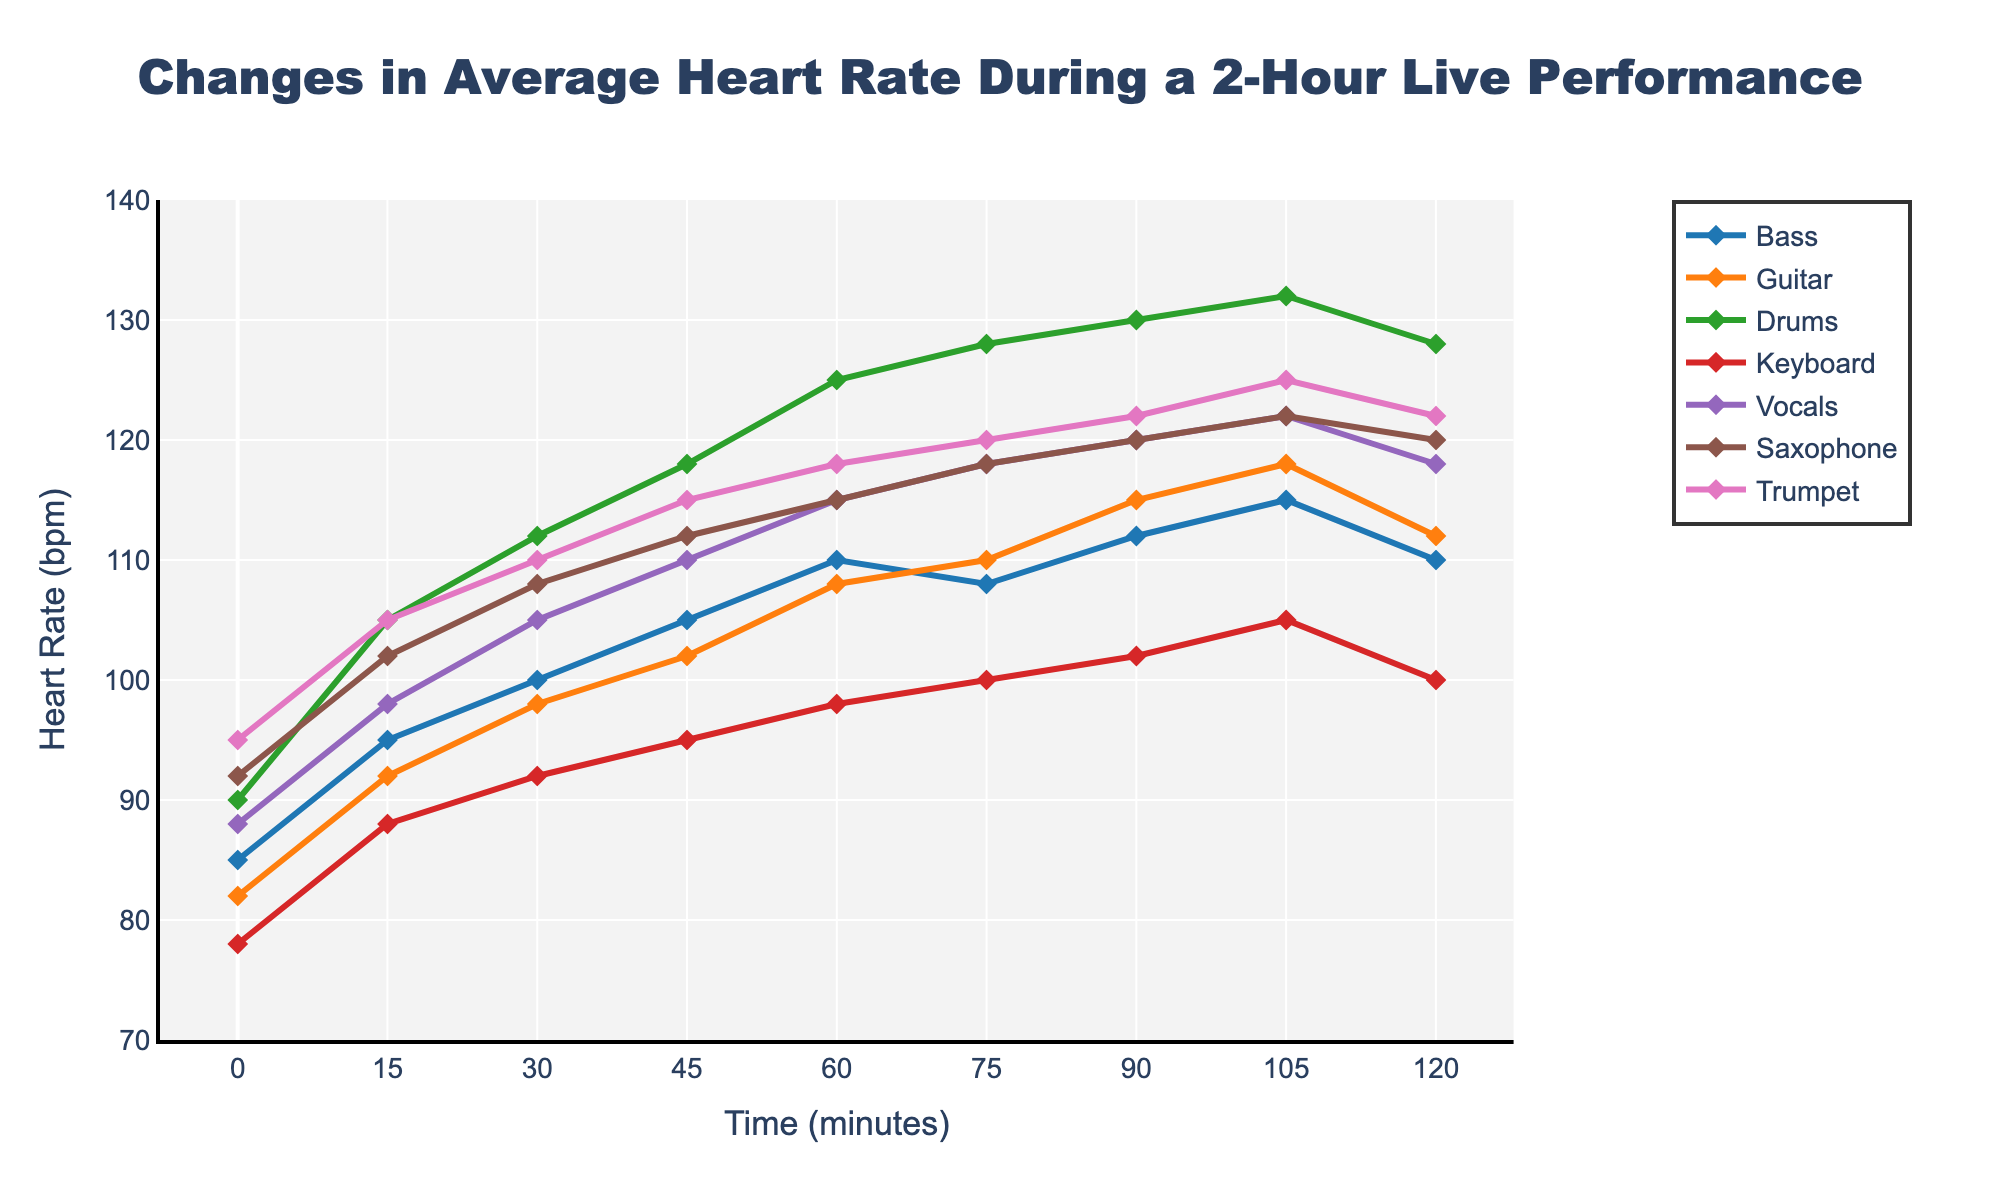Which instrument shows the highest heart rate at the 120-minute mark? Look at the values for each instrument at the 120-minute mark to identify the highest number. Drums have a heart rate of 128 bpm, which is the highest among all instruments.
Answer: Drums Which instrument shows the lowest initial heart rate at the 0-minute mark? Compare the heart rates at the 0-minute mark. Keyboard has the lowest initial heart rate with 78 bpm.
Answer: Keyboard How much does the heart rate of the bassist increase from 0 minutes to 120 minutes? Subtract the initial heart rate (85 bpm at 0 minutes) from the final heart rate (110 bpm at 120 minutes) for the Bass. 110 - 85 = 25 bpm.
Answer: 25 bpm Between which time points does the drummer's heart rate increase the most sharply? Look for the steepest incline in the line representing drums. The sharpest increase occurs between 0 minutes (90 bpm) and 45 minutes (118 bpm), an increase of 28 bpm.
Answer: 0 to 45 minutes Which two instruments have the closest heart rates at the 60-minute mark? Compare the heart rates of each instrument at 60 minutes. Vocals and Trumpet both show a heart rate of 118 bpm, making them the closest.
Answer: Vocals and Trumpet How much does the heart rate of the vocalist increase between 0 and 60 minutes? Subtract the initial heart rate of the vocalist at 0 minutes (88 bpm) from the heart rate at 60 minutes (115 bpm). 115 - 88 = 27 bpm.
Answer: 27 bpm Which instrument shows the most consistent heart rate during the performance? Evaluate which instrument's line has the least variation throughout the performance. The Keyboard's heart rate increases gradually and has the smallest overall range.
Answer: Keyboard How does the heart rate of the saxophonist at 45 minutes compare to the bass player at the same time? Check the heart rate of each at the 45-minute mark. Saxophonist is at 112 bpm, while the bassist is at 105 bpm. Thus, the saxophonist's heart rate is higher by 7 bpm.
Answer: Saxophonist is higher by 7 bpm Which instrument experiences the smallest overall rise in heart rate from 0 minutes to 120 minutes? Calculate the differences for each instrument from 0 minutes to 120 minutes, and find the smallest. Keyboard goes from 78 bpm to 100 bpm, an increase of 22 bpm, which is the smallest rise.
Answer: Keyboard At what time point do all instruments' heart rates generally converge? Look for a point in time where heart rates across all instruments are closest together. At 60 minutes, most heart rates are around 100-118 bpm, indicating convergence.
Answer: 60 minutes 